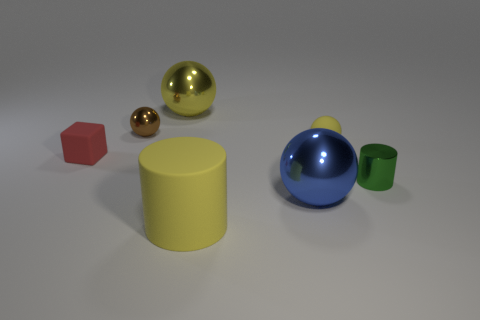Add 2 tiny red rubber things. How many objects exist? 9 Subtract all tiny brown balls. How many balls are left? 3 Subtract all spheres. How many objects are left? 3 Subtract 1 cubes. How many cubes are left? 0 Subtract all green cylinders. How many yellow balls are left? 2 Add 3 cyan metallic things. How many cyan metallic things exist? 3 Subtract all brown balls. How many balls are left? 3 Subtract 1 blue spheres. How many objects are left? 6 Subtract all purple cubes. Subtract all cyan cylinders. How many cubes are left? 1 Subtract all tiny objects. Subtract all blue shiny objects. How many objects are left? 2 